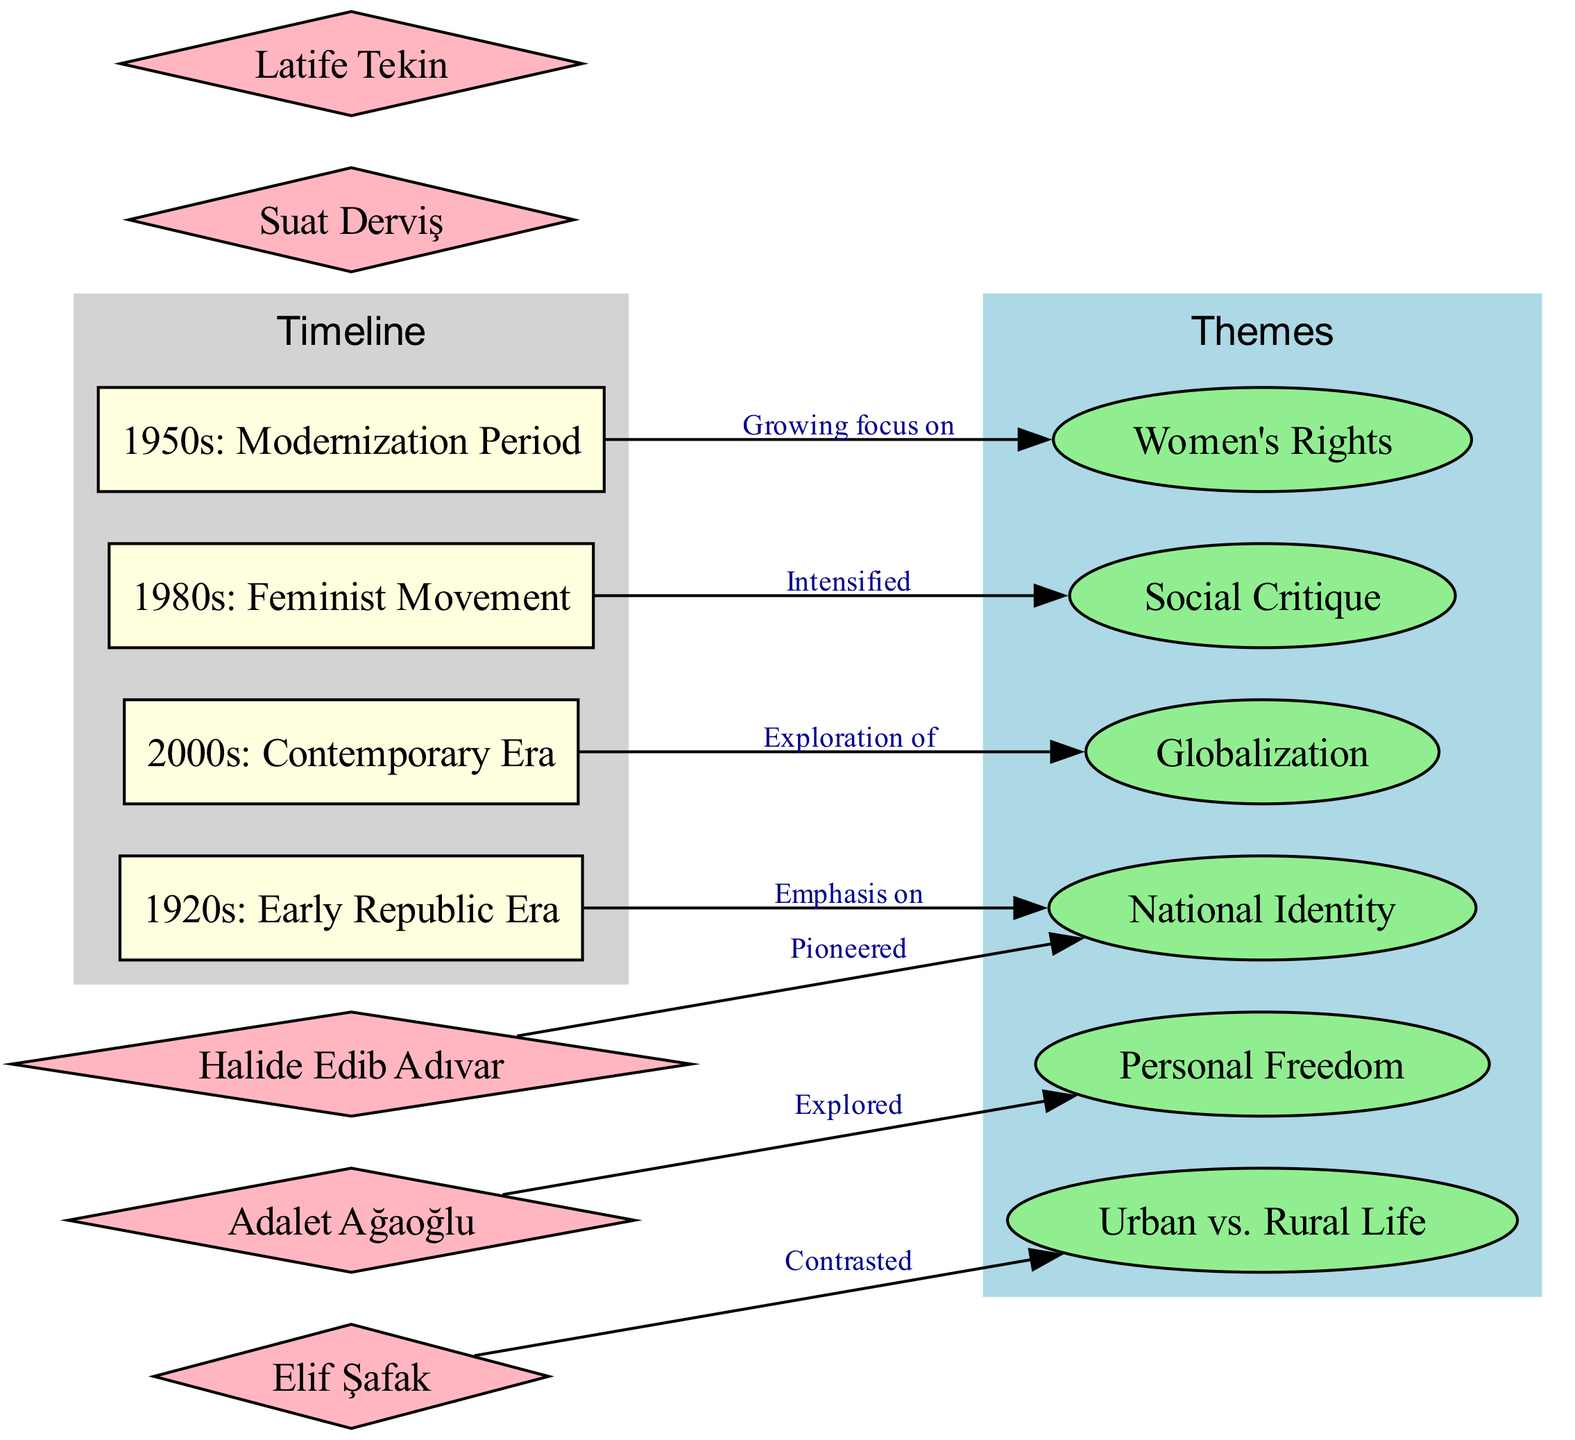What timeline period emphasizes National Identity? By checking the connections from the thematic nodes to the timeline nodes, we see that National Identity is directly connected to the 1920s: Early Republic Era, which indicates an emphasis during this period.
Answer: 1920s: Early Republic Era Which thematic node is connected to the 1980s? Looking at the connections from the timeline nodes to thematic nodes, the 1980s: Feminist Movement is linked to Social Critique, indicating that this theme is associated with this specific era.
Answer: Social Critique How many key authors are represented? By counting the nodes labeled with key authors in the diagram, we find there are five authors included, which can be confirmed by enumerating the names listed.
Answer: 5 What theme is explored by Adalet Ağaoğlu? In examining the connections related to authors, we see that Adalet Ağaoğlu is linked to the theme of Personal Freedom; hence, she explored this theme in her works.
Answer: Personal Freedom Which thematic node has a connection to the 2000s? The connection diagram shows that the 2000s: Contemporary Era is linked to Globalization, making this the thematic node associated with the contemporary period in Turkish women's literature.
Answer: Globalization What is the relationship between Halide Edib Adıvar and National Identity? The diagram indicates a direct connection where Halide Edib Adıvar is labeled as having pioneered National Identity, establishing a significant relationship between the author and this thematic concept.
Answer: Pioneered How does Elif Şafak's work contrast Urban vs. Rural Life? Based on the connections visible in the diagram, Elif Şafak is shown to have a specific connection to the theme of Urban vs. Rural Life, which indicates that her works include contrasts between these two aspects.
Answer: Contrasted Identify the thematic node that was emphasized during the Modernization Period. By analyzing the connection from the 1950s: Modernization Period to the thematic nodes, we find that Women's Rights was the paramount theme during this timeframe, reflecting its significance in literature of that era.
Answer: Women's Rights 